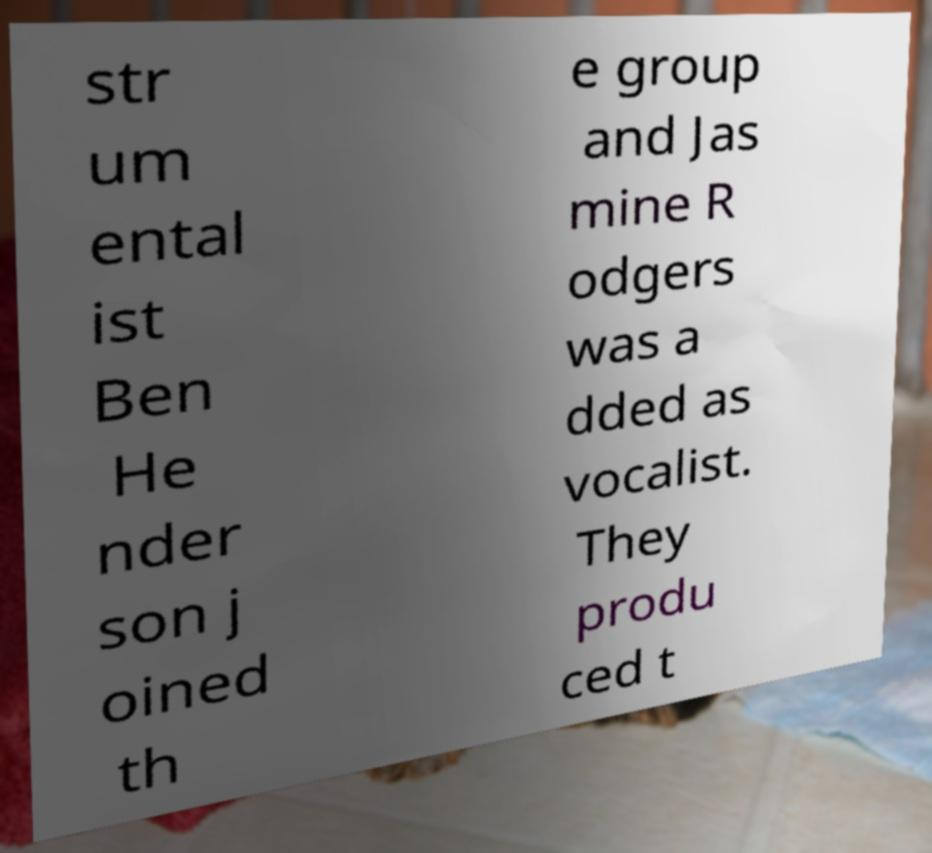Can you accurately transcribe the text from the provided image for me? str um ental ist Ben He nder son j oined th e group and Jas mine R odgers was a dded as vocalist. They produ ced t 